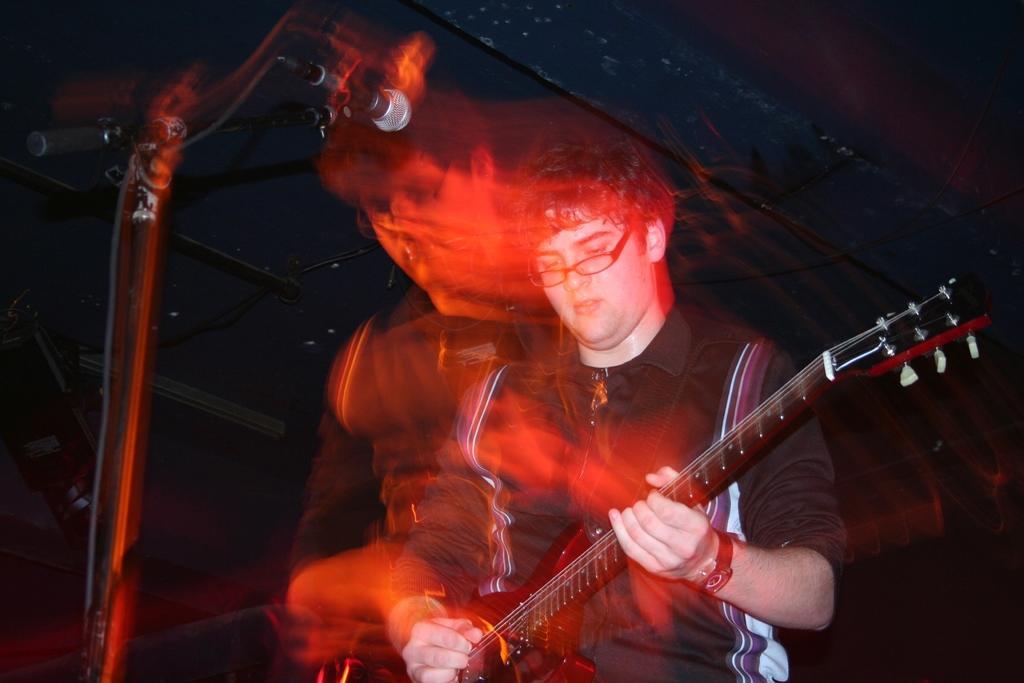Could you give a brief overview of what you see in this image? In this picture there is a man who is playing a guitar. There is also a mic. 